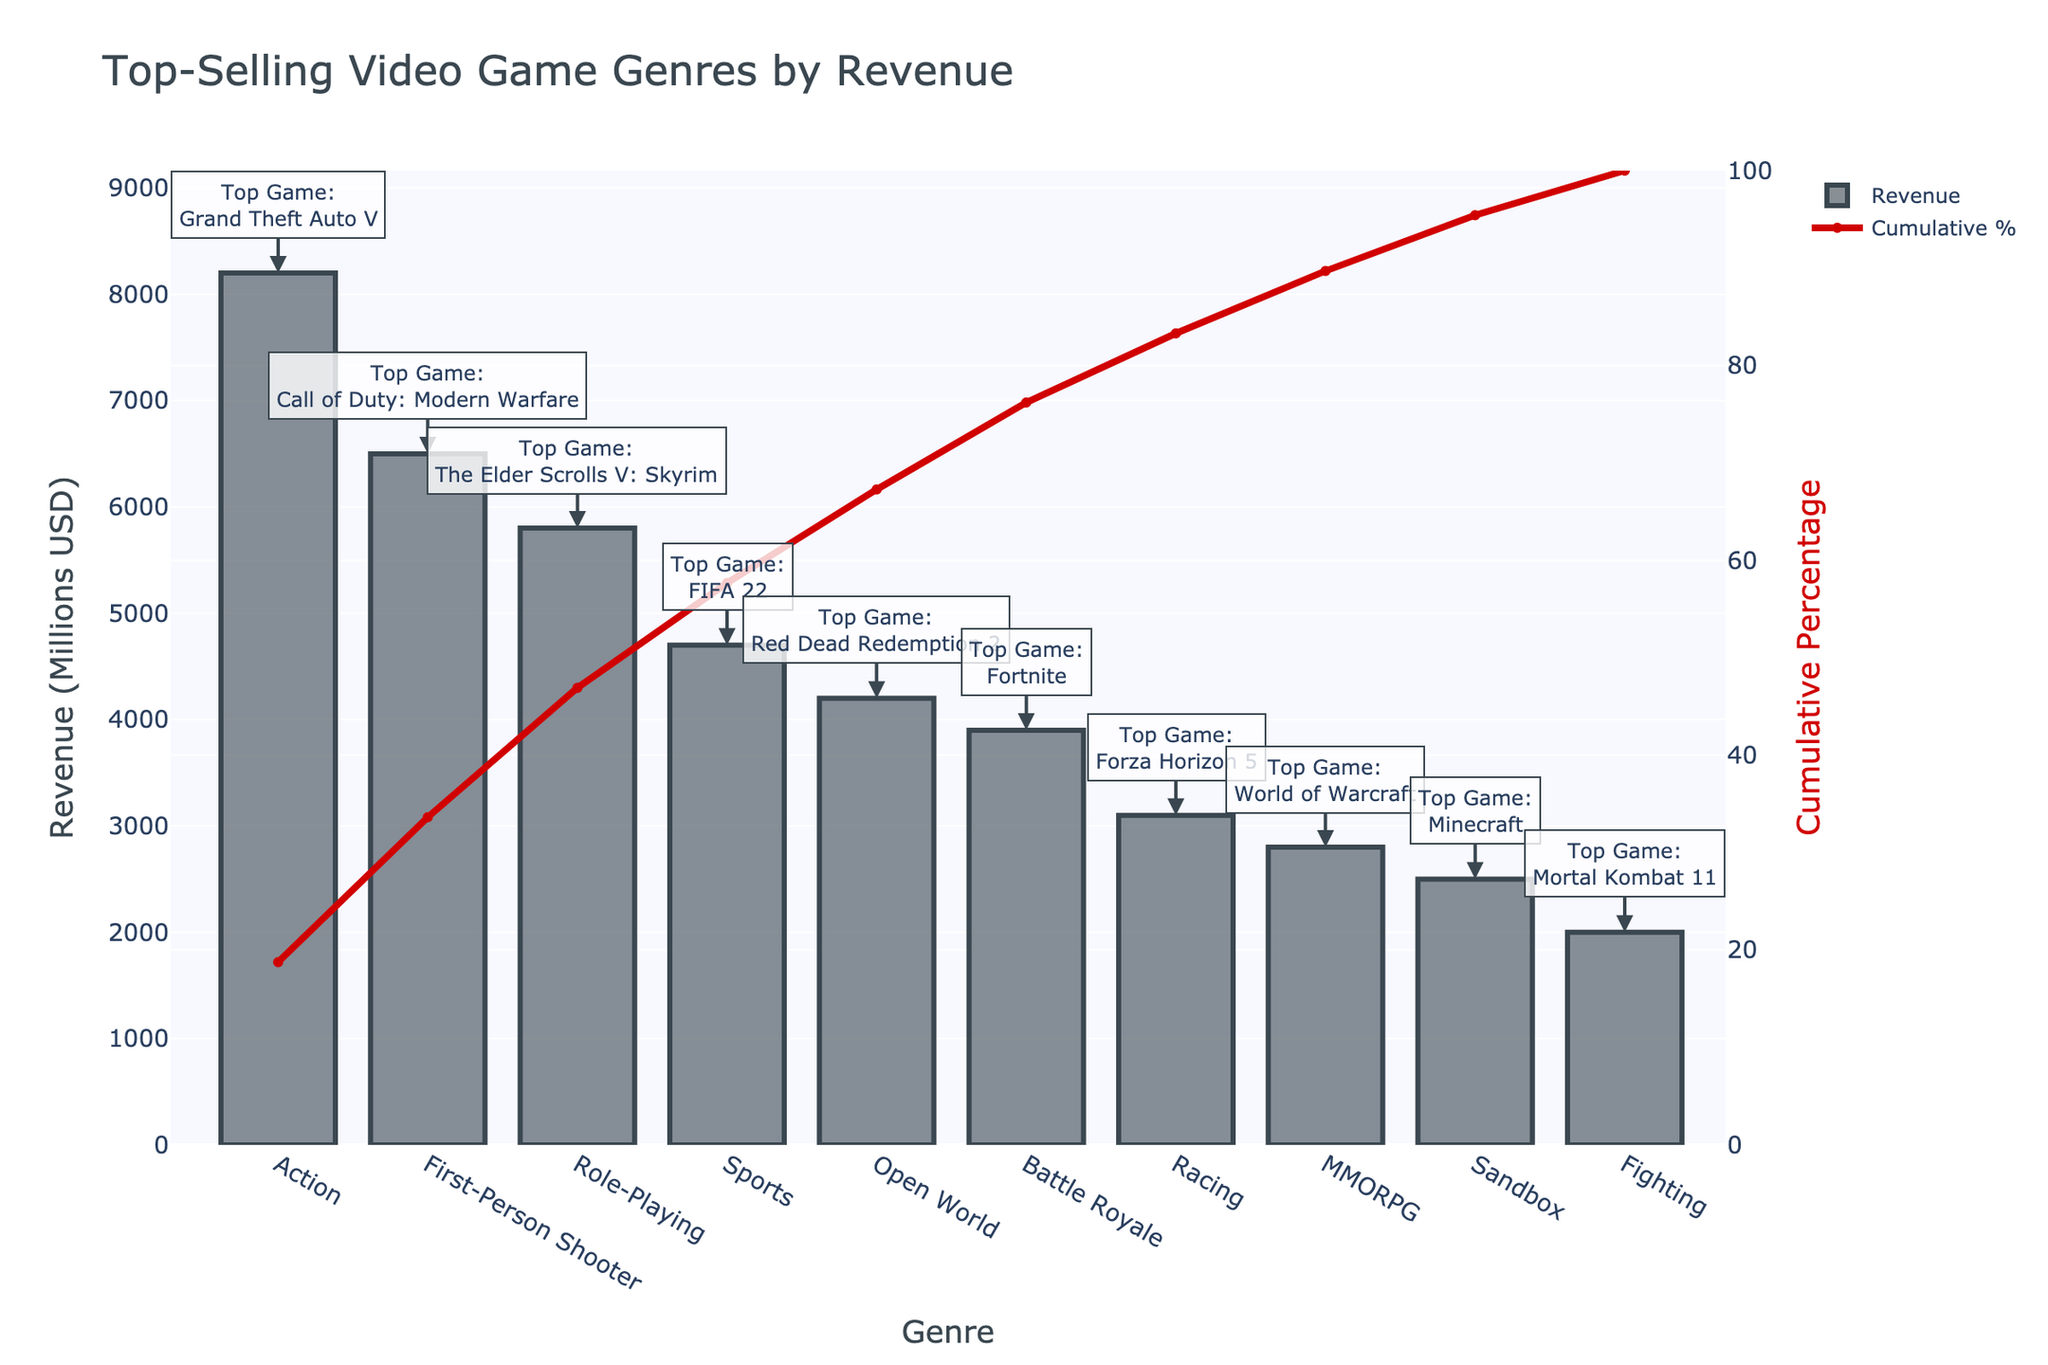what’s the title of the chart? The title of the chart is prominently displayed at the top.
Answer: Top-Selling Video Game Genres by Revenue Which genre has the highest revenue? The genre with the highest bar and highest value on the y-axis represents the highest revenue.
Answer: Action What’s the revenue for the Sports genre? Locate the Sports genre on the x-axis, and then check the corresponding bar height on the y-axis.
Answer: 4700 Million USD What’s the cumulative percentage for MMORPG? Find MMORPG on the x-axis, and follow the point of the cumulative percentage (line graph) on the right y-axis.
Answer: 95% What is the top game title in the Battle Royale genre? Check the annotation for the Battle Royale bar, which specifies the top game title.
Answer: Fortnite What’s the difference in revenue between Action and Racing genres? Subtract the revenue of Racing (3100) from Action (8200). (8200 - 3100 = 5100)
Answer: 5100 Million USD Which genre has higher revenue: First-Person Shooter or Role-Playing? Compare the heights of the bars for FPS and Role-Playing on the y-axis. FPS is higher.
Answer: First-Person Shooter How many genres contribute to 50% cumulative percentage of the revenue? Check the line graph and find where it crosses the 50% mark on the right y-axis. Then count the genres up to that point.
Answer: 3 genres What’s the average revenue of the top three genres? Sum the revenues of the top three genres (8200, 6500, 5800) and divide by 3. ((8200 + 6500 + 5800) / 3 = 6833.33)
Answer: 6833.33 Million USD How does the cumulative percentage help interpret the chart? The cumulative percentage helps identify the proportion of revenue contributed by the top genres. It also helps in understanding how much of the total revenue is captured by the leading genres in a Pareto principle context.
Answer: It shows the proportion of revenue contribution 